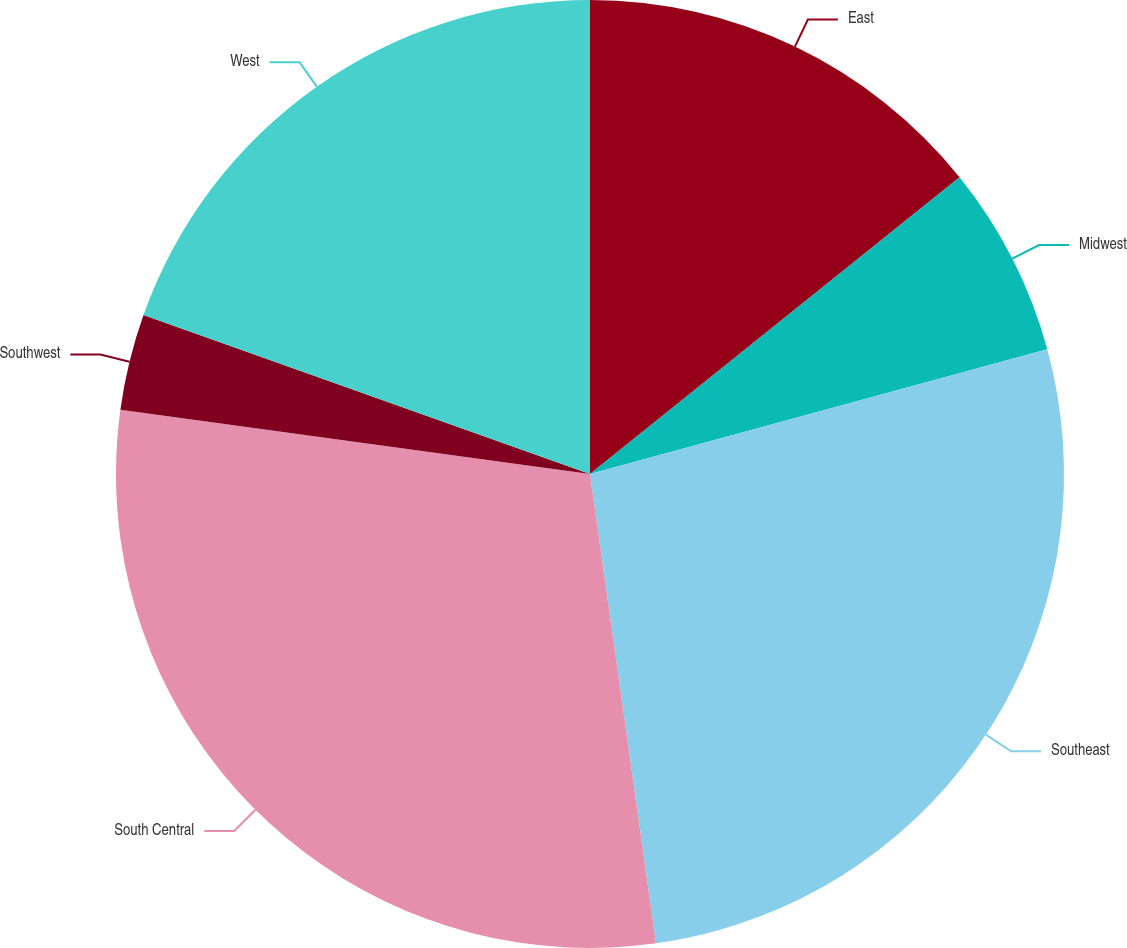Convert chart. <chart><loc_0><loc_0><loc_500><loc_500><pie_chart><fcel>East<fcel>Midwest<fcel>Southeast<fcel>South Central<fcel>Southwest<fcel>West<nl><fcel>14.23%<fcel>6.53%<fcel>27.01%<fcel>29.39%<fcel>3.28%<fcel>19.55%<nl></chart> 